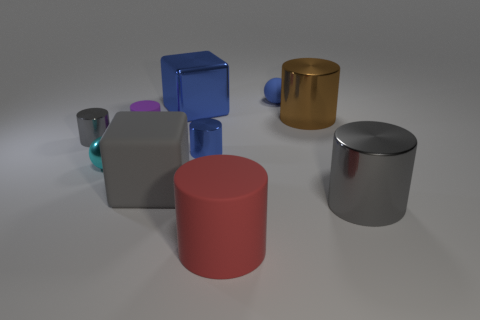Does the tiny gray cylinder have the same material as the blue cube?
Offer a terse response. Yes. What is the shape of the thing that is left of the gray cube and in front of the tiny gray cylinder?
Offer a very short reply. Sphere. There is a brown thing that is made of the same material as the cyan thing; what shape is it?
Provide a short and direct response. Cylinder. Is there a small gray metal cylinder?
Give a very brief answer. Yes. Are there any small purple cylinders that are behind the big block behind the shiny ball?
Your answer should be very brief. No. There is a brown thing that is the same shape as the tiny blue metal object; what material is it?
Ensure brevity in your answer.  Metal. Is the number of things greater than the number of cylinders?
Your response must be concise. Yes. There is a small rubber ball; does it have the same color as the cube that is on the left side of the large blue cube?
Offer a terse response. No. The shiny cylinder that is both right of the small purple matte cylinder and left of the tiny blue ball is what color?
Your answer should be compact. Blue. How many other things are there of the same material as the brown cylinder?
Offer a terse response. 5. 